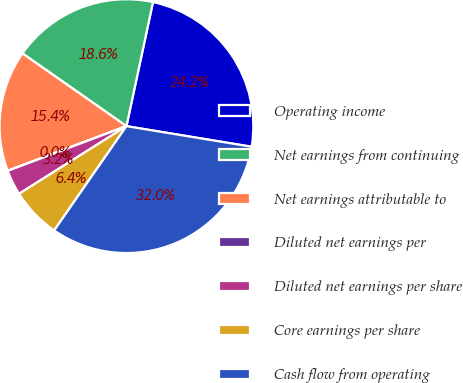Convert chart. <chart><loc_0><loc_0><loc_500><loc_500><pie_chart><fcel>Operating income<fcel>Net earnings from continuing<fcel>Net earnings attributable to<fcel>Diluted net earnings per<fcel>Diluted net earnings per share<fcel>Core earnings per share<fcel>Cash flow from operating<nl><fcel>24.24%<fcel>18.64%<fcel>15.44%<fcel>0.01%<fcel>3.21%<fcel>6.41%<fcel>32.05%<nl></chart> 